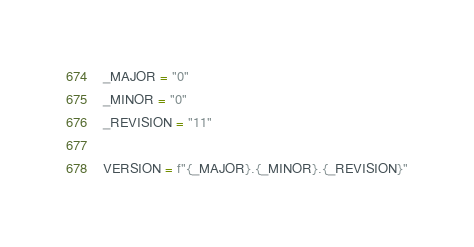<code> <loc_0><loc_0><loc_500><loc_500><_Python_>_MAJOR = "0"
_MINOR = "0"
_REVISION = "11"

VERSION = f"{_MAJOR}.{_MINOR}.{_REVISION}"
</code> 